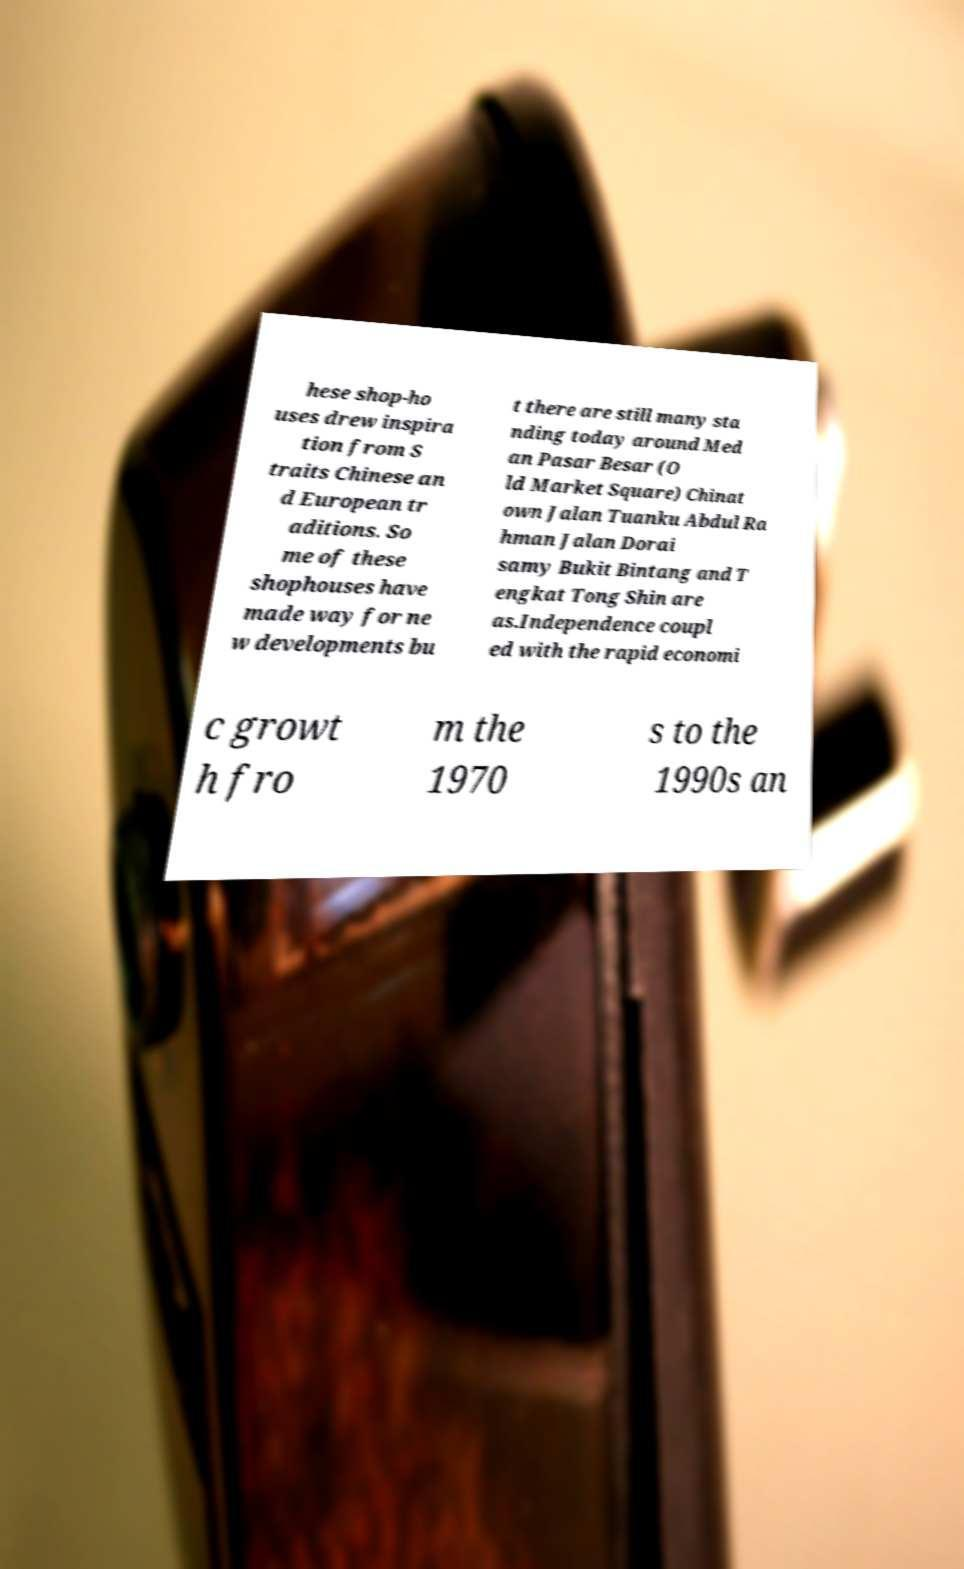I need the written content from this picture converted into text. Can you do that? hese shop-ho uses drew inspira tion from S traits Chinese an d European tr aditions. So me of these shophouses have made way for ne w developments bu t there are still many sta nding today around Med an Pasar Besar (O ld Market Square) Chinat own Jalan Tuanku Abdul Ra hman Jalan Dorai samy Bukit Bintang and T engkat Tong Shin are as.Independence coupl ed with the rapid economi c growt h fro m the 1970 s to the 1990s an 